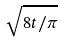Convert formula to latex. <formula><loc_0><loc_0><loc_500><loc_500>\sqrt { 8 t / \pi }</formula> 